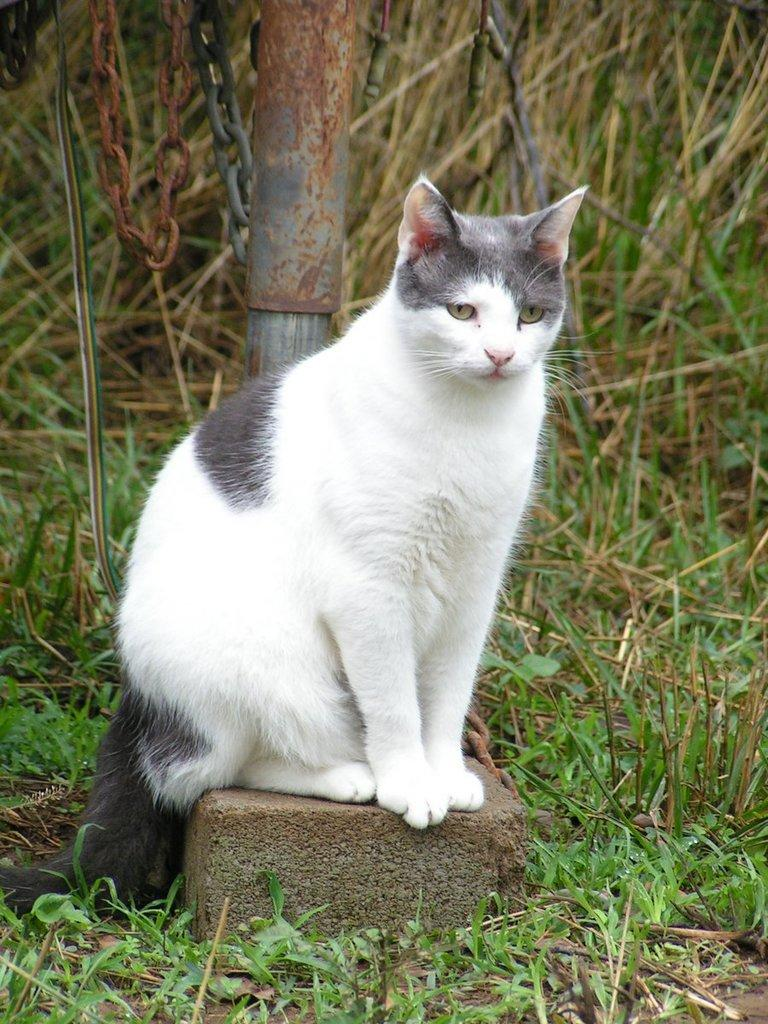What type of animal is in the image? There is a white color cat in the image. What is the cat standing on? The cat is on a brick. Where is the brick located? The brick is placed on the ground. What type of vegetation is on the ground? There is grass on the ground. What can be seen in the background of the image? There is a pole in the background of the image. What is attached to the pole? There is a chain associated with the pole. What type of reaction can be seen from the cat when it starts teaching a class in the image? There is no indication in the image that the cat is teaching a class, and therefore no such reaction can be observed. 